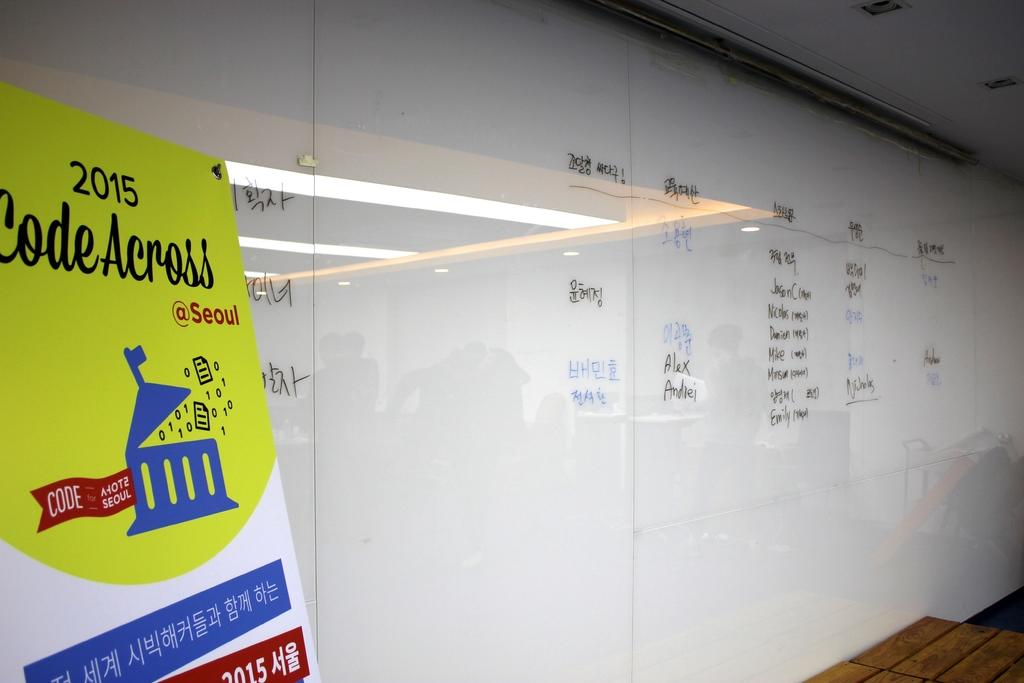<image>
Write a terse but informative summary of the picture. A large white board and a sign that says 2015 Code Across. 